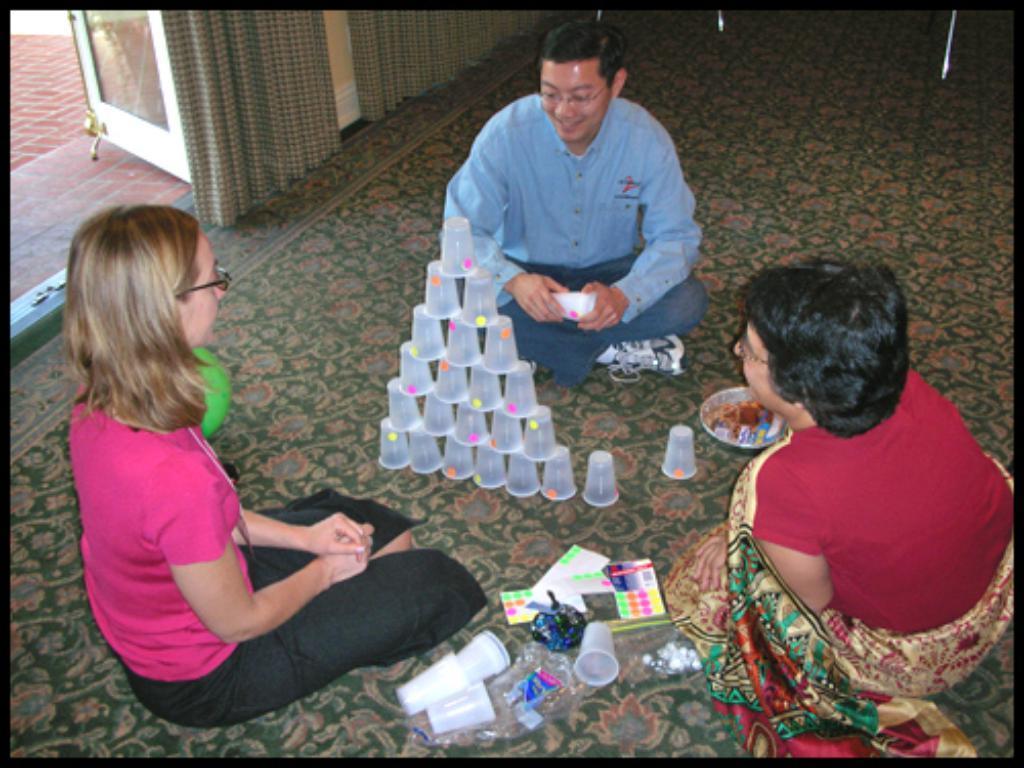Could you give a brief overview of what you see in this image? As we can see in the image there are curtains, door, three people sitting on floor, glasses, book and plate. 